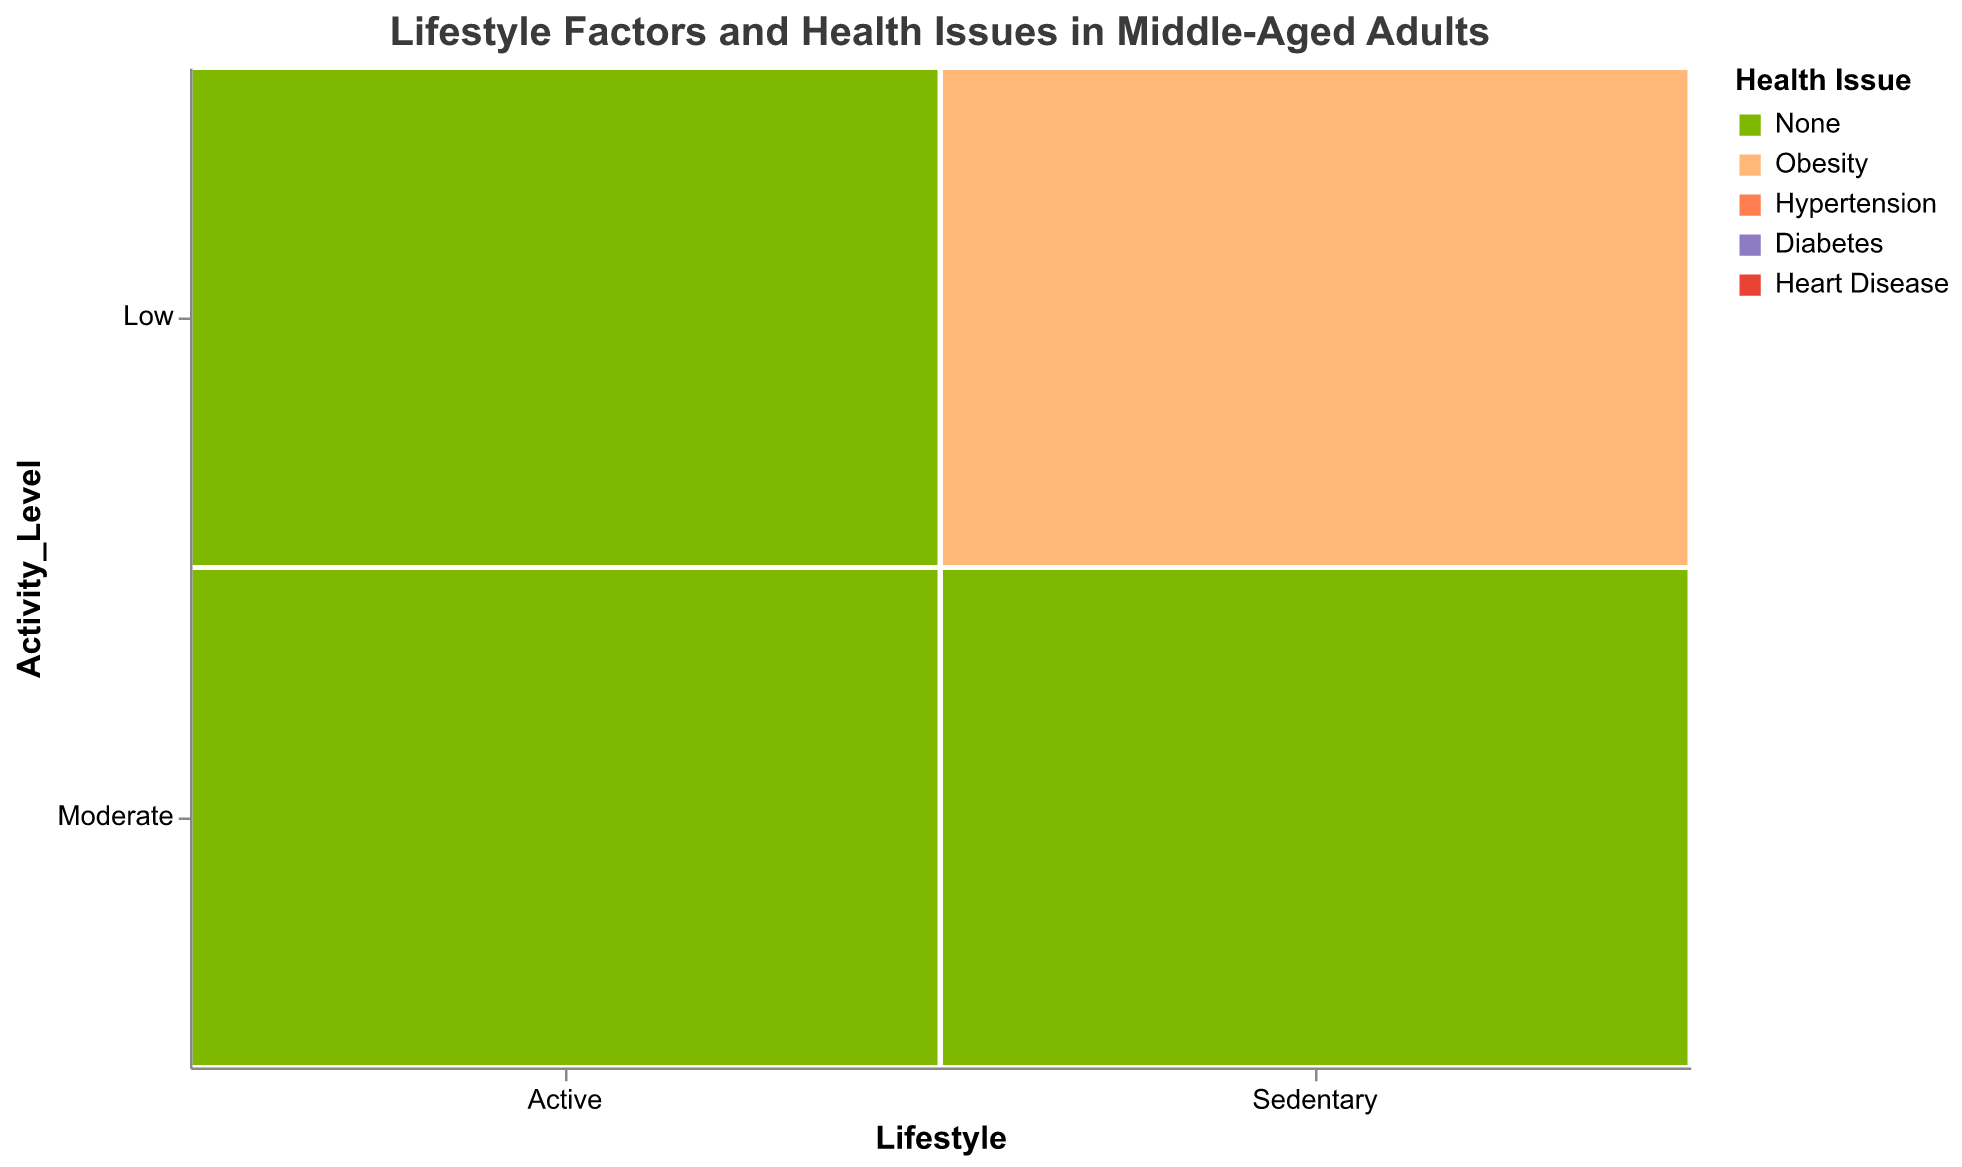How many health issues are depicted in the plot? The plot's legend shows five different health issues with associated colors. These include None, Obesity, Hypertension, Diabetes, and Heart Disease.
Answer: Five What is the health issue common among Sedentary individuals with Low activity level, Unhealthy diet, and who smoke? The intersection of Sedentary lifestyle, Low activity level, Unhealthy diet, and Smoking shows Heart Disease.
Answer: Heart Disease Which lifestyle and activity level are associated with the highest variety of health issues for individuals following an Unhealthy diet and smoking? By looking at the Unhealthy diet and Smoking columns, Sedentary lifestyle and Low activity level display Heart Disease, Diabetes, and Hypertension.
Answer: Sedentary and Low Are there any health issues identified for active individuals with a moderate activity level, a healthy diet, and who do not smoke? This combination shows 'None' in the plot, indicating no health issues.
Answer: None Compare the health issues between active and sedentary people with a moderate activity level and a healthy diet who do not smoke. For Active individuals, the plot shows 'None,' meaning no health issues. For Sedentary individuals, it also shows 'None,' indicating no health issues in both groups.
Answer: Both None For sedentary individuals, what effect does increasing their activity level from low to moderate have on health issues, assuming they have a healthy diet and do not smoke? For Sedentary individuals with Low activity and a Healthy diet who do not smoke, Obesity is shown. For Moderate activity and the same diet and smoking status, no health issues are shown. Thus, increasing activity level appears to eliminate obesity.
Answer: Reduces Obesity Which group has the most visually diverse health issues: Active or Sedentary individuals? Sedentary individuals exhibit Heart Disease, Diabetes, Hypertension, Obesity, None. In contrast, Active individuals show Heart Disease, Hypertension, Obesity, None. Therefore, Sedentary individuals have more variety in health issues.
Answer: Sedentary Do sedentary individuals with a moderate activity level and unhealthy diet have more issues if smoking or not? Both smoking and non-smoking groups under these conditions show Heart Disease and Diabetes, suggesting an equivalent number of health issues regardless of smoking status.
Answer: Equivalent What is the health issue status for Active individuals with Low activity and a healthy diet who do not smoke? The corresponding cell in the plot shows 'None,' indicating no health issues.
Answer: None 